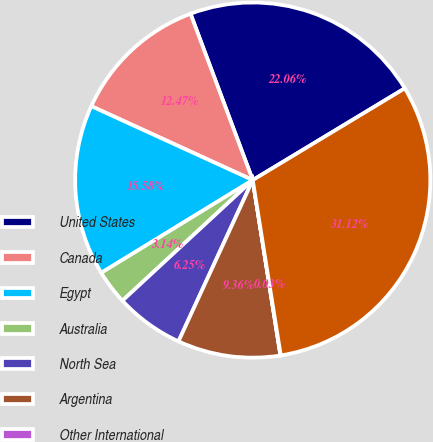<chart> <loc_0><loc_0><loc_500><loc_500><pie_chart><fcel>United States<fcel>Canada<fcel>Egypt<fcel>Australia<fcel>North Sea<fcel>Argentina<fcel>Other International<fcel>Total<nl><fcel>22.06%<fcel>12.47%<fcel>15.58%<fcel>3.14%<fcel>6.25%<fcel>9.36%<fcel>0.03%<fcel>31.12%<nl></chart> 